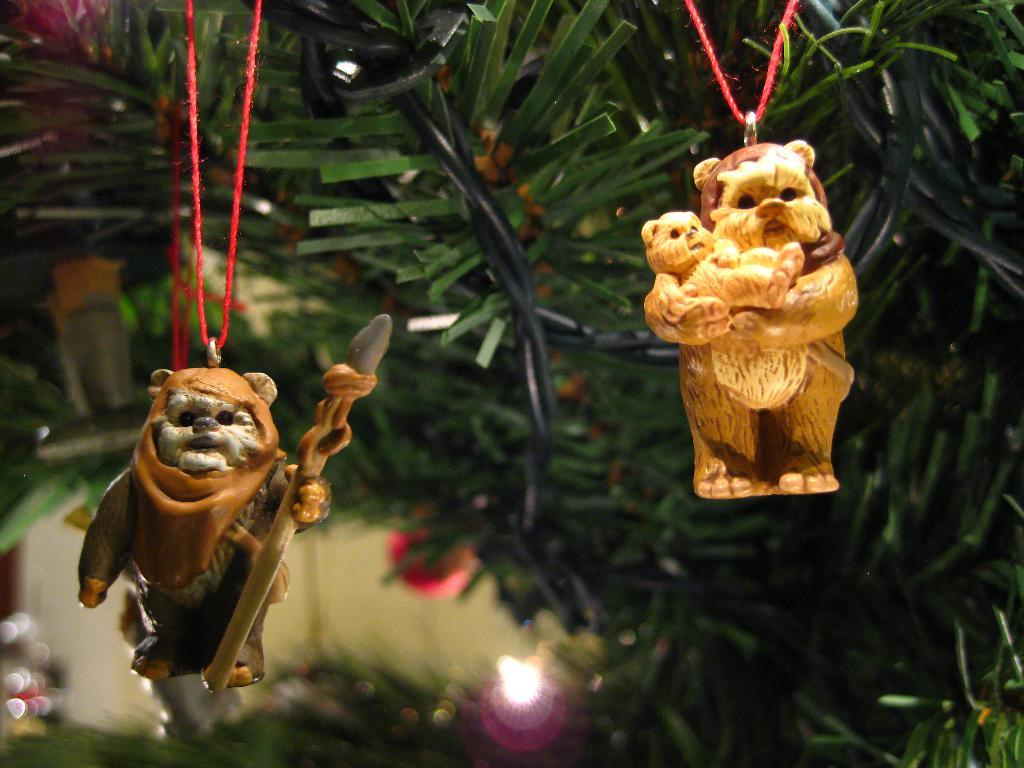What type of objects can be seen in the image? There are toys in the image. What additional feature is present in the image? Decorative lights areative lights are visible in the image. Is there a fight happening between the toys in the image? There is no indication of a fight in the image; it only shows toys and decorative lights. What type of grass can be seen in the image? There is no grass present in the image. 